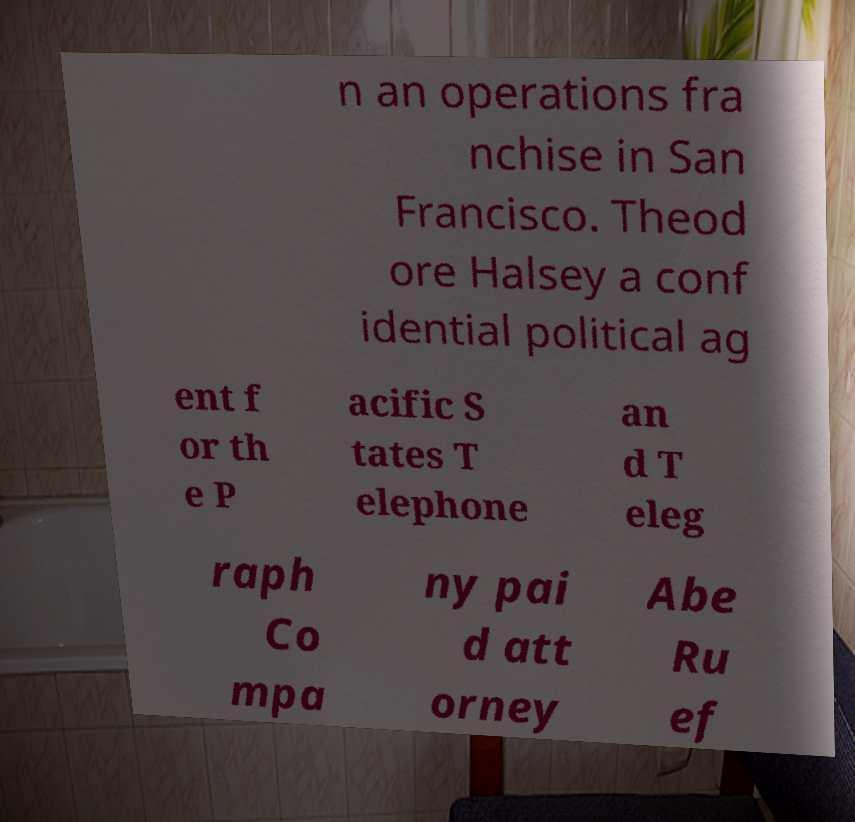What messages or text are displayed in this image? I need them in a readable, typed format. n an operations fra nchise in San Francisco. Theod ore Halsey a conf idential political ag ent f or th e P acific S tates T elephone an d T eleg raph Co mpa ny pai d att orney Abe Ru ef 